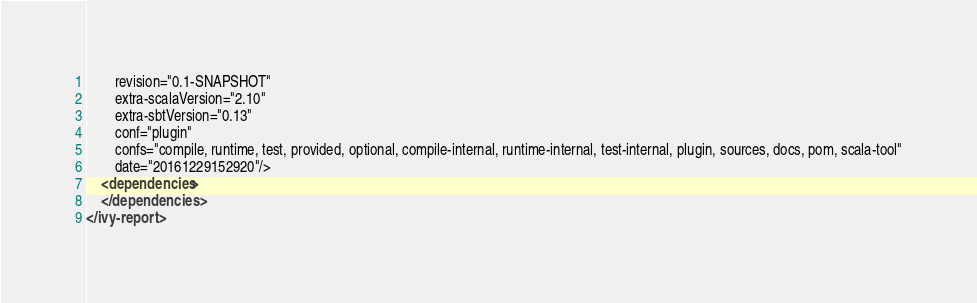Convert code to text. <code><loc_0><loc_0><loc_500><loc_500><_XML_>		revision="0.1-SNAPSHOT"
		extra-scalaVersion="2.10"
		extra-sbtVersion="0.13"
		conf="plugin"
		confs="compile, runtime, test, provided, optional, compile-internal, runtime-internal, test-internal, plugin, sources, docs, pom, scala-tool"
		date="20161229152920"/>
	<dependencies>
	</dependencies>
</ivy-report>
</code> 